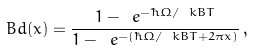Convert formula to latex. <formula><loc_0><loc_0><loc_500><loc_500>\ B d ( x ) = \frac { 1 - \ e ^ { - \hbar { \Omega } / \ k B T } } { 1 - \ e ^ { - ( \hbar { \Omega } / \ k B T + 2 \pi x ) } } \, ,</formula> 